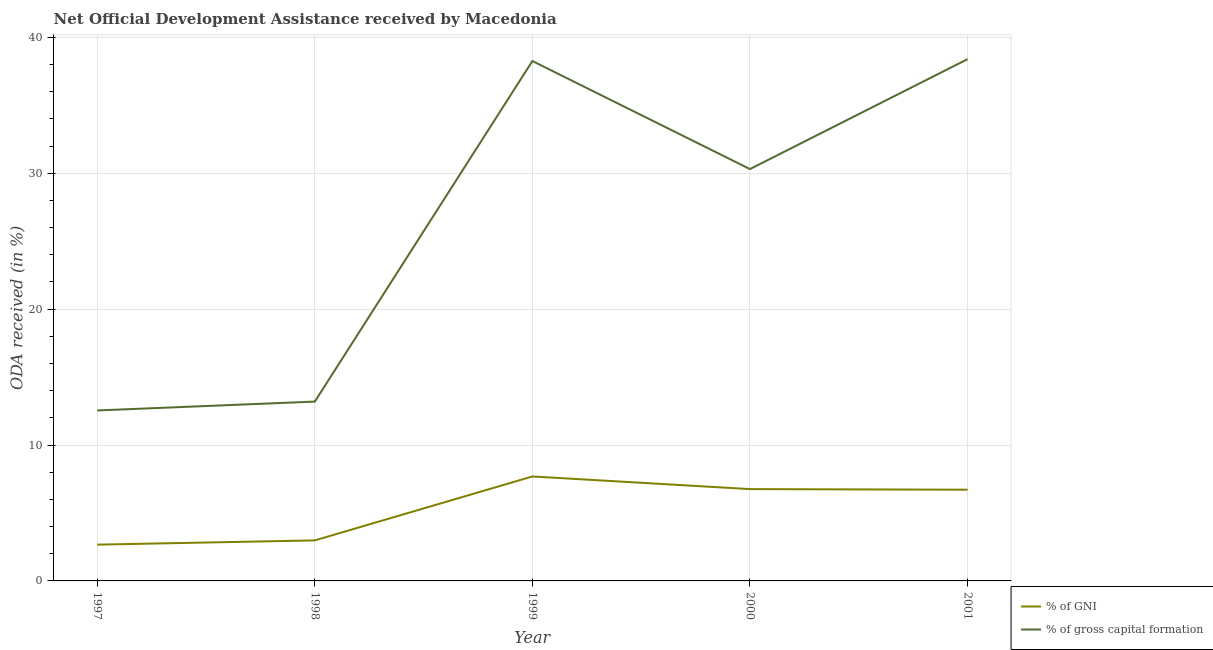How many different coloured lines are there?
Your answer should be compact. 2. Does the line corresponding to oda received as percentage of gni intersect with the line corresponding to oda received as percentage of gross capital formation?
Your response must be concise. No. What is the oda received as percentage of gross capital formation in 2001?
Offer a very short reply. 38.4. Across all years, what is the maximum oda received as percentage of gross capital formation?
Your answer should be compact. 38.4. Across all years, what is the minimum oda received as percentage of gni?
Provide a succinct answer. 2.67. In which year was the oda received as percentage of gni maximum?
Provide a succinct answer. 1999. What is the total oda received as percentage of gross capital formation in the graph?
Keep it short and to the point. 132.7. What is the difference between the oda received as percentage of gni in 1998 and that in 2000?
Your answer should be very brief. -3.77. What is the difference between the oda received as percentage of gni in 2001 and the oda received as percentage of gross capital formation in 1999?
Provide a succinct answer. -31.55. What is the average oda received as percentage of gross capital formation per year?
Your answer should be compact. 26.54. In the year 2001, what is the difference between the oda received as percentage of gross capital formation and oda received as percentage of gni?
Your answer should be compact. 31.68. What is the ratio of the oda received as percentage of gni in 1997 to that in 2000?
Keep it short and to the point. 0.4. Is the oda received as percentage of gni in 1998 less than that in 2001?
Your response must be concise. Yes. What is the difference between the highest and the second highest oda received as percentage of gross capital formation?
Offer a very short reply. 0.14. What is the difference between the highest and the lowest oda received as percentage of gross capital formation?
Provide a short and direct response. 25.85. Does the oda received as percentage of gni monotonically increase over the years?
Your response must be concise. No. Is the oda received as percentage of gni strictly less than the oda received as percentage of gross capital formation over the years?
Ensure brevity in your answer.  Yes. How many years are there in the graph?
Your response must be concise. 5. What is the difference between two consecutive major ticks on the Y-axis?
Ensure brevity in your answer.  10. Are the values on the major ticks of Y-axis written in scientific E-notation?
Your response must be concise. No. Does the graph contain grids?
Offer a very short reply. Yes. How many legend labels are there?
Give a very brief answer. 2. What is the title of the graph?
Your answer should be compact. Net Official Development Assistance received by Macedonia. Does "Number of departures" appear as one of the legend labels in the graph?
Offer a terse response. No. What is the label or title of the X-axis?
Make the answer very short. Year. What is the label or title of the Y-axis?
Offer a very short reply. ODA received (in %). What is the ODA received (in %) in % of GNI in 1997?
Make the answer very short. 2.67. What is the ODA received (in %) of % of gross capital formation in 1997?
Make the answer very short. 12.54. What is the ODA received (in %) in % of GNI in 1998?
Your answer should be compact. 2.98. What is the ODA received (in %) of % of gross capital formation in 1998?
Your response must be concise. 13.2. What is the ODA received (in %) in % of GNI in 1999?
Your response must be concise. 7.69. What is the ODA received (in %) in % of gross capital formation in 1999?
Your answer should be very brief. 38.26. What is the ODA received (in %) of % of GNI in 2000?
Provide a short and direct response. 6.76. What is the ODA received (in %) of % of gross capital formation in 2000?
Your answer should be compact. 30.31. What is the ODA received (in %) of % of GNI in 2001?
Make the answer very short. 6.71. What is the ODA received (in %) of % of gross capital formation in 2001?
Give a very brief answer. 38.4. Across all years, what is the maximum ODA received (in %) of % of GNI?
Offer a terse response. 7.69. Across all years, what is the maximum ODA received (in %) of % of gross capital formation?
Offer a terse response. 38.4. Across all years, what is the minimum ODA received (in %) in % of GNI?
Give a very brief answer. 2.67. Across all years, what is the minimum ODA received (in %) in % of gross capital formation?
Offer a very short reply. 12.54. What is the total ODA received (in %) of % of GNI in the graph?
Offer a very short reply. 26.81. What is the total ODA received (in %) of % of gross capital formation in the graph?
Keep it short and to the point. 132.7. What is the difference between the ODA received (in %) in % of GNI in 1997 and that in 1998?
Your answer should be very brief. -0.31. What is the difference between the ODA received (in %) of % of gross capital formation in 1997 and that in 1998?
Provide a short and direct response. -0.65. What is the difference between the ODA received (in %) of % of GNI in 1997 and that in 1999?
Make the answer very short. -5.02. What is the difference between the ODA received (in %) of % of gross capital formation in 1997 and that in 1999?
Provide a succinct answer. -25.71. What is the difference between the ODA received (in %) of % of GNI in 1997 and that in 2000?
Provide a succinct answer. -4.09. What is the difference between the ODA received (in %) of % of gross capital formation in 1997 and that in 2000?
Offer a terse response. -17.76. What is the difference between the ODA received (in %) in % of GNI in 1997 and that in 2001?
Keep it short and to the point. -4.04. What is the difference between the ODA received (in %) in % of gross capital formation in 1997 and that in 2001?
Keep it short and to the point. -25.85. What is the difference between the ODA received (in %) in % of GNI in 1998 and that in 1999?
Ensure brevity in your answer.  -4.7. What is the difference between the ODA received (in %) of % of gross capital formation in 1998 and that in 1999?
Your answer should be very brief. -25.06. What is the difference between the ODA received (in %) of % of GNI in 1998 and that in 2000?
Provide a short and direct response. -3.77. What is the difference between the ODA received (in %) in % of gross capital formation in 1998 and that in 2000?
Keep it short and to the point. -17.11. What is the difference between the ODA received (in %) of % of GNI in 1998 and that in 2001?
Provide a short and direct response. -3.73. What is the difference between the ODA received (in %) in % of gross capital formation in 1998 and that in 2001?
Offer a very short reply. -25.2. What is the difference between the ODA received (in %) in % of GNI in 1999 and that in 2000?
Keep it short and to the point. 0.93. What is the difference between the ODA received (in %) in % of gross capital formation in 1999 and that in 2000?
Ensure brevity in your answer.  7.95. What is the difference between the ODA received (in %) of % of GNI in 1999 and that in 2001?
Ensure brevity in your answer.  0.97. What is the difference between the ODA received (in %) in % of gross capital formation in 1999 and that in 2001?
Provide a succinct answer. -0.14. What is the difference between the ODA received (in %) in % of GNI in 2000 and that in 2001?
Provide a succinct answer. 0.04. What is the difference between the ODA received (in %) of % of gross capital formation in 2000 and that in 2001?
Keep it short and to the point. -8.09. What is the difference between the ODA received (in %) in % of GNI in 1997 and the ODA received (in %) in % of gross capital formation in 1998?
Keep it short and to the point. -10.53. What is the difference between the ODA received (in %) in % of GNI in 1997 and the ODA received (in %) in % of gross capital formation in 1999?
Your answer should be very brief. -35.59. What is the difference between the ODA received (in %) of % of GNI in 1997 and the ODA received (in %) of % of gross capital formation in 2000?
Give a very brief answer. -27.64. What is the difference between the ODA received (in %) of % of GNI in 1997 and the ODA received (in %) of % of gross capital formation in 2001?
Offer a very short reply. -35.73. What is the difference between the ODA received (in %) of % of GNI in 1998 and the ODA received (in %) of % of gross capital formation in 1999?
Your answer should be compact. -35.28. What is the difference between the ODA received (in %) of % of GNI in 1998 and the ODA received (in %) of % of gross capital formation in 2000?
Your answer should be compact. -27.33. What is the difference between the ODA received (in %) of % of GNI in 1998 and the ODA received (in %) of % of gross capital formation in 2001?
Your answer should be very brief. -35.41. What is the difference between the ODA received (in %) in % of GNI in 1999 and the ODA received (in %) in % of gross capital formation in 2000?
Offer a very short reply. -22.62. What is the difference between the ODA received (in %) of % of GNI in 1999 and the ODA received (in %) of % of gross capital formation in 2001?
Your response must be concise. -30.71. What is the difference between the ODA received (in %) of % of GNI in 2000 and the ODA received (in %) of % of gross capital formation in 2001?
Provide a short and direct response. -31.64. What is the average ODA received (in %) in % of GNI per year?
Keep it short and to the point. 5.36. What is the average ODA received (in %) of % of gross capital formation per year?
Ensure brevity in your answer.  26.54. In the year 1997, what is the difference between the ODA received (in %) of % of GNI and ODA received (in %) of % of gross capital formation?
Your response must be concise. -9.88. In the year 1998, what is the difference between the ODA received (in %) of % of GNI and ODA received (in %) of % of gross capital formation?
Make the answer very short. -10.21. In the year 1999, what is the difference between the ODA received (in %) in % of GNI and ODA received (in %) in % of gross capital formation?
Provide a succinct answer. -30.57. In the year 2000, what is the difference between the ODA received (in %) in % of GNI and ODA received (in %) in % of gross capital formation?
Offer a terse response. -23.55. In the year 2001, what is the difference between the ODA received (in %) in % of GNI and ODA received (in %) in % of gross capital formation?
Keep it short and to the point. -31.68. What is the ratio of the ODA received (in %) of % of GNI in 1997 to that in 1998?
Keep it short and to the point. 0.9. What is the ratio of the ODA received (in %) of % of gross capital formation in 1997 to that in 1998?
Offer a terse response. 0.95. What is the ratio of the ODA received (in %) in % of GNI in 1997 to that in 1999?
Provide a succinct answer. 0.35. What is the ratio of the ODA received (in %) of % of gross capital formation in 1997 to that in 1999?
Ensure brevity in your answer.  0.33. What is the ratio of the ODA received (in %) in % of GNI in 1997 to that in 2000?
Ensure brevity in your answer.  0.4. What is the ratio of the ODA received (in %) in % of gross capital formation in 1997 to that in 2000?
Provide a short and direct response. 0.41. What is the ratio of the ODA received (in %) of % of GNI in 1997 to that in 2001?
Your answer should be compact. 0.4. What is the ratio of the ODA received (in %) of % of gross capital formation in 1997 to that in 2001?
Provide a succinct answer. 0.33. What is the ratio of the ODA received (in %) in % of GNI in 1998 to that in 1999?
Keep it short and to the point. 0.39. What is the ratio of the ODA received (in %) in % of gross capital formation in 1998 to that in 1999?
Your response must be concise. 0.34. What is the ratio of the ODA received (in %) of % of GNI in 1998 to that in 2000?
Offer a terse response. 0.44. What is the ratio of the ODA received (in %) in % of gross capital formation in 1998 to that in 2000?
Give a very brief answer. 0.44. What is the ratio of the ODA received (in %) in % of GNI in 1998 to that in 2001?
Make the answer very short. 0.44. What is the ratio of the ODA received (in %) of % of gross capital formation in 1998 to that in 2001?
Keep it short and to the point. 0.34. What is the ratio of the ODA received (in %) of % of GNI in 1999 to that in 2000?
Provide a succinct answer. 1.14. What is the ratio of the ODA received (in %) in % of gross capital formation in 1999 to that in 2000?
Give a very brief answer. 1.26. What is the ratio of the ODA received (in %) of % of GNI in 1999 to that in 2001?
Keep it short and to the point. 1.15. What is the ratio of the ODA received (in %) in % of gross capital formation in 2000 to that in 2001?
Your answer should be compact. 0.79. What is the difference between the highest and the second highest ODA received (in %) in % of GNI?
Your answer should be very brief. 0.93. What is the difference between the highest and the second highest ODA received (in %) in % of gross capital formation?
Provide a succinct answer. 0.14. What is the difference between the highest and the lowest ODA received (in %) in % of GNI?
Give a very brief answer. 5.02. What is the difference between the highest and the lowest ODA received (in %) of % of gross capital formation?
Make the answer very short. 25.85. 